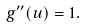Convert formula to latex. <formula><loc_0><loc_0><loc_500><loc_500>g ^ { \prime \prime } ( u ) = 1 .</formula> 